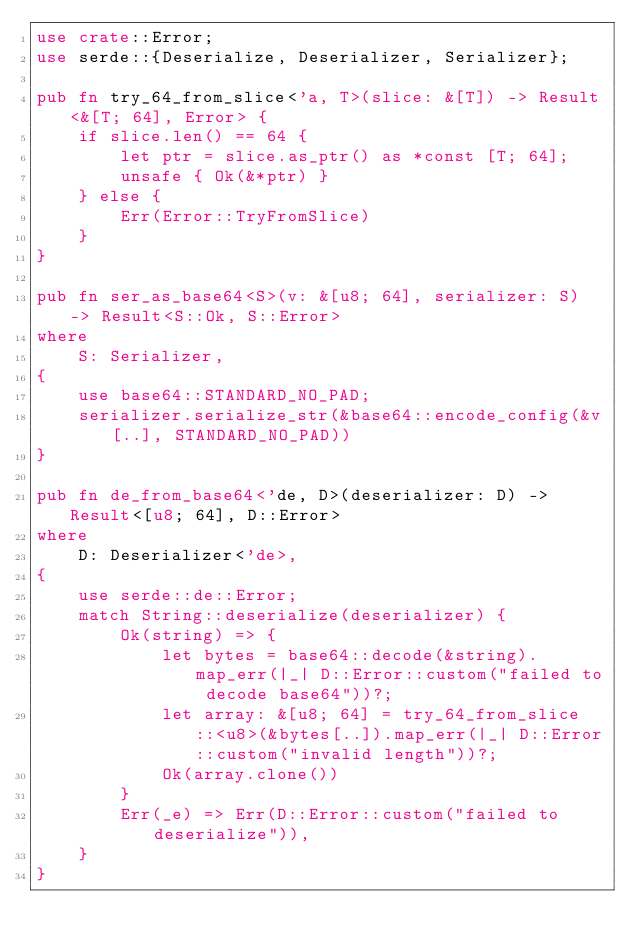Convert code to text. <code><loc_0><loc_0><loc_500><loc_500><_Rust_>use crate::Error;
use serde::{Deserialize, Deserializer, Serializer};

pub fn try_64_from_slice<'a, T>(slice: &[T]) -> Result<&[T; 64], Error> {
    if slice.len() == 64 {
        let ptr = slice.as_ptr() as *const [T; 64];
        unsafe { Ok(&*ptr) }
    } else {
        Err(Error::TryFromSlice)
    }
}

pub fn ser_as_base64<S>(v: &[u8; 64], serializer: S) -> Result<S::Ok, S::Error>
where
    S: Serializer,
{
    use base64::STANDARD_NO_PAD;
    serializer.serialize_str(&base64::encode_config(&v[..], STANDARD_NO_PAD))
}

pub fn de_from_base64<'de, D>(deserializer: D) -> Result<[u8; 64], D::Error>
where
    D: Deserializer<'de>,
{
    use serde::de::Error;
    match String::deserialize(deserializer) {
        Ok(string) => {
            let bytes = base64::decode(&string).map_err(|_| D::Error::custom("failed to decode base64"))?;
            let array: &[u8; 64] = try_64_from_slice::<u8>(&bytes[..]).map_err(|_| D::Error::custom("invalid length"))?;
            Ok(array.clone())
        }
        Err(_e) => Err(D::Error::custom("failed to deserialize")),
    }
}
</code> 